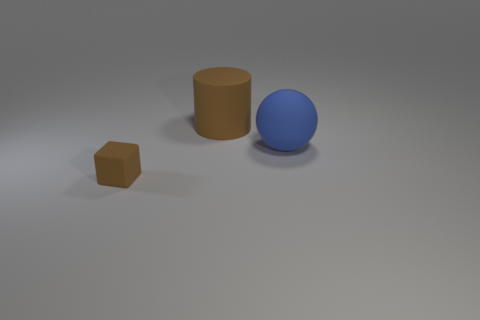Do the big blue sphere and the thing that is in front of the blue rubber ball have the same material?
Your answer should be compact. Yes. How many brown things are either rubber spheres or tiny cubes?
Provide a short and direct response. 1. Is there another brown matte cylinder that has the same size as the cylinder?
Provide a short and direct response. No. The brown thing to the right of the brown object to the left of the brown rubber thing that is behind the brown rubber cube is made of what material?
Provide a short and direct response. Rubber. Are there an equal number of brown blocks that are behind the small brown matte cube and rubber objects?
Offer a very short reply. No. Is the material of the brown object to the right of the brown cube the same as the large thing to the right of the large matte cylinder?
Offer a very short reply. Yes. What number of things are green objects or brown rubber objects on the right side of the tiny matte block?
Keep it short and to the point. 1. Is there another rubber object of the same shape as the tiny brown thing?
Provide a succinct answer. No. There is a brown object in front of the brown thing behind the object in front of the blue rubber sphere; what is its size?
Ensure brevity in your answer.  Small. Are there the same number of big rubber things that are in front of the small cube and tiny objects that are behind the blue object?
Your response must be concise. Yes. 